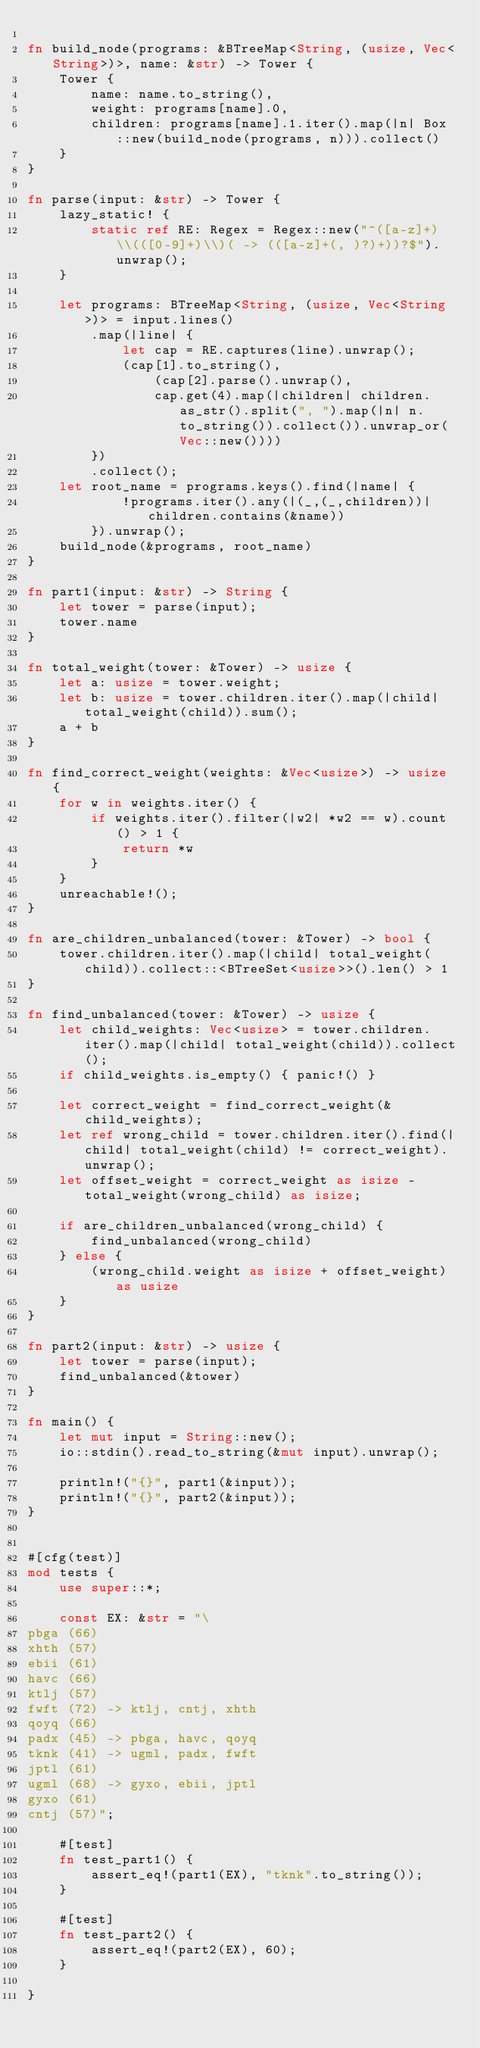<code> <loc_0><loc_0><loc_500><loc_500><_Rust_>
fn build_node(programs: &BTreeMap<String, (usize, Vec<String>)>, name: &str) -> Tower {
    Tower {
        name: name.to_string(),
        weight: programs[name].0,
        children: programs[name].1.iter().map(|n| Box::new(build_node(programs, n))).collect()
    }
}

fn parse(input: &str) -> Tower {
    lazy_static! {
        static ref RE: Regex = Regex::new("^([a-z]+) \\(([0-9]+)\\)( -> (([a-z]+(, )?)+))?$").unwrap();
    }

    let programs: BTreeMap<String, (usize, Vec<String>)> = input.lines()
        .map(|line| {
            let cap = RE.captures(line).unwrap();
            (cap[1].to_string(),
                (cap[2].parse().unwrap(),
                cap.get(4).map(|children| children.as_str().split(", ").map(|n| n.to_string()).collect()).unwrap_or(Vec::new())))
        })
        .collect();
    let root_name = programs.keys().find(|name| {
            !programs.iter().any(|(_,(_,children))| children.contains(&name))
        }).unwrap();
    build_node(&programs, root_name)
}

fn part1(input: &str) -> String {
    let tower = parse(input);
    tower.name
}

fn total_weight(tower: &Tower) -> usize {
    let a: usize = tower.weight;
    let b: usize = tower.children.iter().map(|child| total_weight(child)).sum();
    a + b
}

fn find_correct_weight(weights: &Vec<usize>) -> usize {
    for w in weights.iter() {
        if weights.iter().filter(|w2| *w2 == w).count() > 1 {
            return *w
        }
    }
    unreachable!();
}

fn are_children_unbalanced(tower: &Tower) -> bool {
    tower.children.iter().map(|child| total_weight(child)).collect::<BTreeSet<usize>>().len() > 1
}

fn find_unbalanced(tower: &Tower) -> usize {
    let child_weights: Vec<usize> = tower.children.iter().map(|child| total_weight(child)).collect();
    if child_weights.is_empty() { panic!() }

    let correct_weight = find_correct_weight(&child_weights);
    let ref wrong_child = tower.children.iter().find(|child| total_weight(child) != correct_weight).unwrap();
    let offset_weight = correct_weight as isize - total_weight(wrong_child) as isize;

    if are_children_unbalanced(wrong_child) {
        find_unbalanced(wrong_child)
    } else {
        (wrong_child.weight as isize + offset_weight) as usize
    }
}

fn part2(input: &str) -> usize {
    let tower = parse(input);
    find_unbalanced(&tower)
}

fn main() {
    let mut input = String::new();
    io::stdin().read_to_string(&mut input).unwrap();

    println!("{}", part1(&input));
    println!("{}", part2(&input));
}


#[cfg(test)]
mod tests {
    use super::*;

    const EX: &str = "\
pbga (66)
xhth (57)
ebii (61)
havc (66)
ktlj (57)
fwft (72) -> ktlj, cntj, xhth
qoyq (66)
padx (45) -> pbga, havc, qoyq
tknk (41) -> ugml, padx, fwft
jptl (61)
ugml (68) -> gyxo, ebii, jptl
gyxo (61)
cntj (57)";

    #[test]
    fn test_part1() {
        assert_eq!(part1(EX), "tknk".to_string());
    }

    #[test]
    fn test_part2() {
        assert_eq!(part2(EX), 60);
    }

}
</code> 